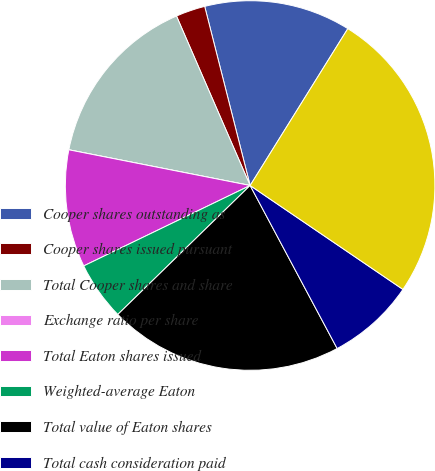Convert chart to OTSL. <chart><loc_0><loc_0><loc_500><loc_500><pie_chart><fcel>Cooper shares outstanding as<fcel>Cooper shares issued pursuant<fcel>Total Cooper shares and share<fcel>Exchange ratio per share<fcel>Total Eaton shares issued<fcel>Weighted-average Eaton<fcel>Total value of Eaton shares<fcel>Total cash consideration paid<fcel>Total consideration<nl><fcel>12.82%<fcel>2.57%<fcel>15.38%<fcel>0.0%<fcel>10.26%<fcel>5.13%<fcel>20.51%<fcel>7.69%<fcel>25.64%<nl></chart> 